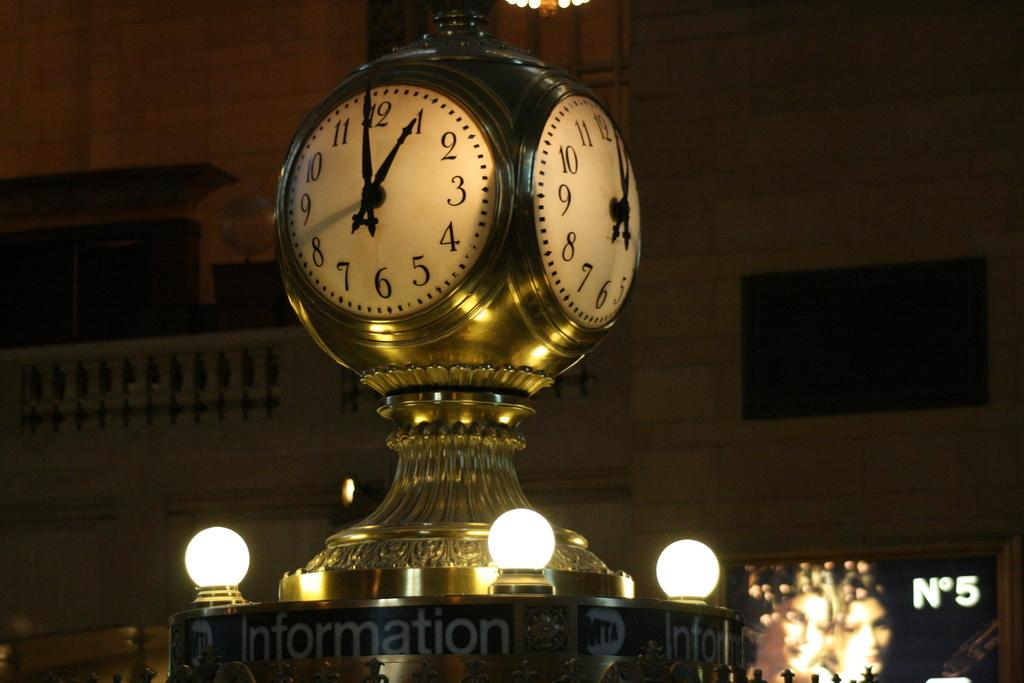Provide a one-sentence caption for the provided image. Clock that has the word Information right below it. 